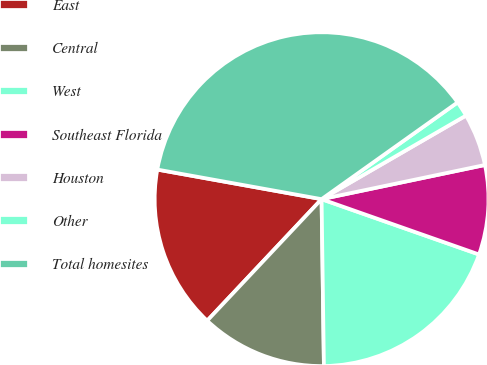Convert chart. <chart><loc_0><loc_0><loc_500><loc_500><pie_chart><fcel>East<fcel>Central<fcel>West<fcel>Southeast Florida<fcel>Houston<fcel>Other<fcel>Total homesites<nl><fcel>15.82%<fcel>12.24%<fcel>19.4%<fcel>8.66%<fcel>5.07%<fcel>1.49%<fcel>37.32%<nl></chart> 